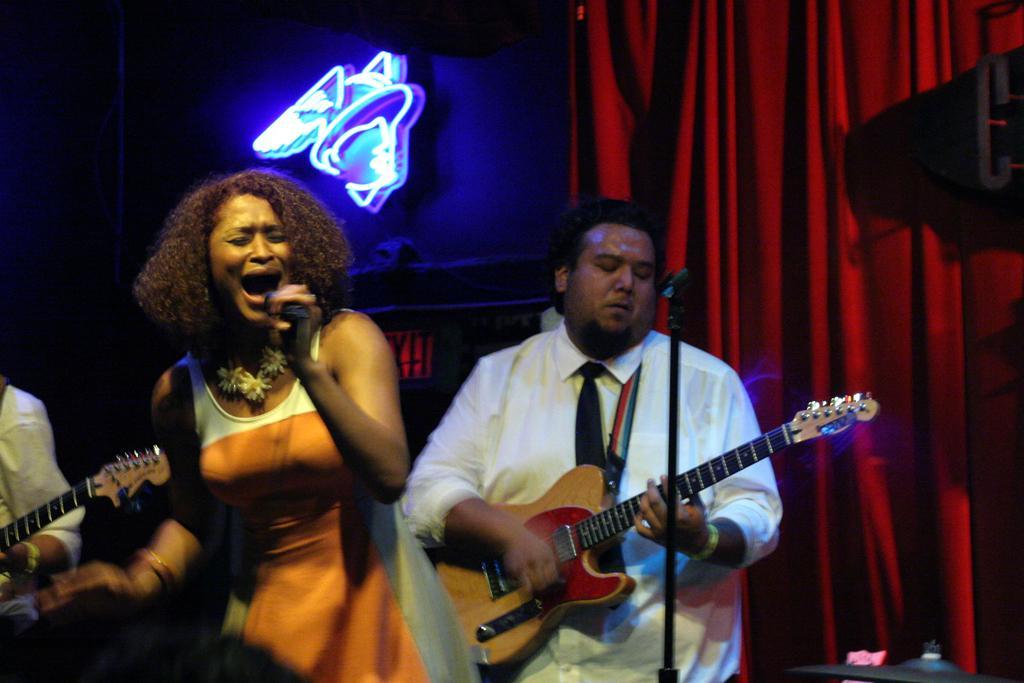Can you describe this image briefly? In this image I see a woman who is holding the mic and I see a man who is holding the guitar and I see another over here who is also holding the guitar. In the background I see the curtain and the light. 